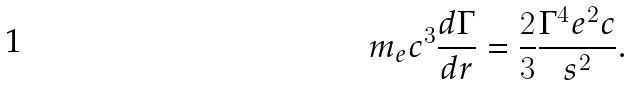Convert formula to latex. <formula><loc_0><loc_0><loc_500><loc_500>m _ { e } c ^ { 3 } \frac { d \Gamma } { d r } = \frac { 2 } { 3 } \frac { \Gamma ^ { 4 } e ^ { 2 } c } { s ^ { 2 } } .</formula> 